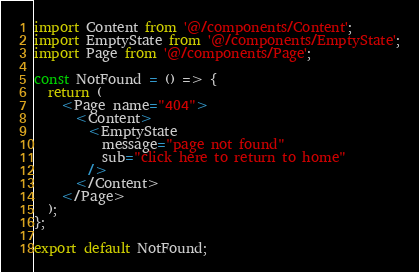<code> <loc_0><loc_0><loc_500><loc_500><_JavaScript_>import Content from '@/components/Content';
import EmptyState from '@/components/EmptyState';
import Page from '@/components/Page';

const NotFound = () => {
  return (
    <Page name="404">
      <Content>
        <EmptyState
          message="page not found"
          sub="click here to return to home"
        />
      </Content>
    </Page>
  );
};

export default NotFound;
</code> 